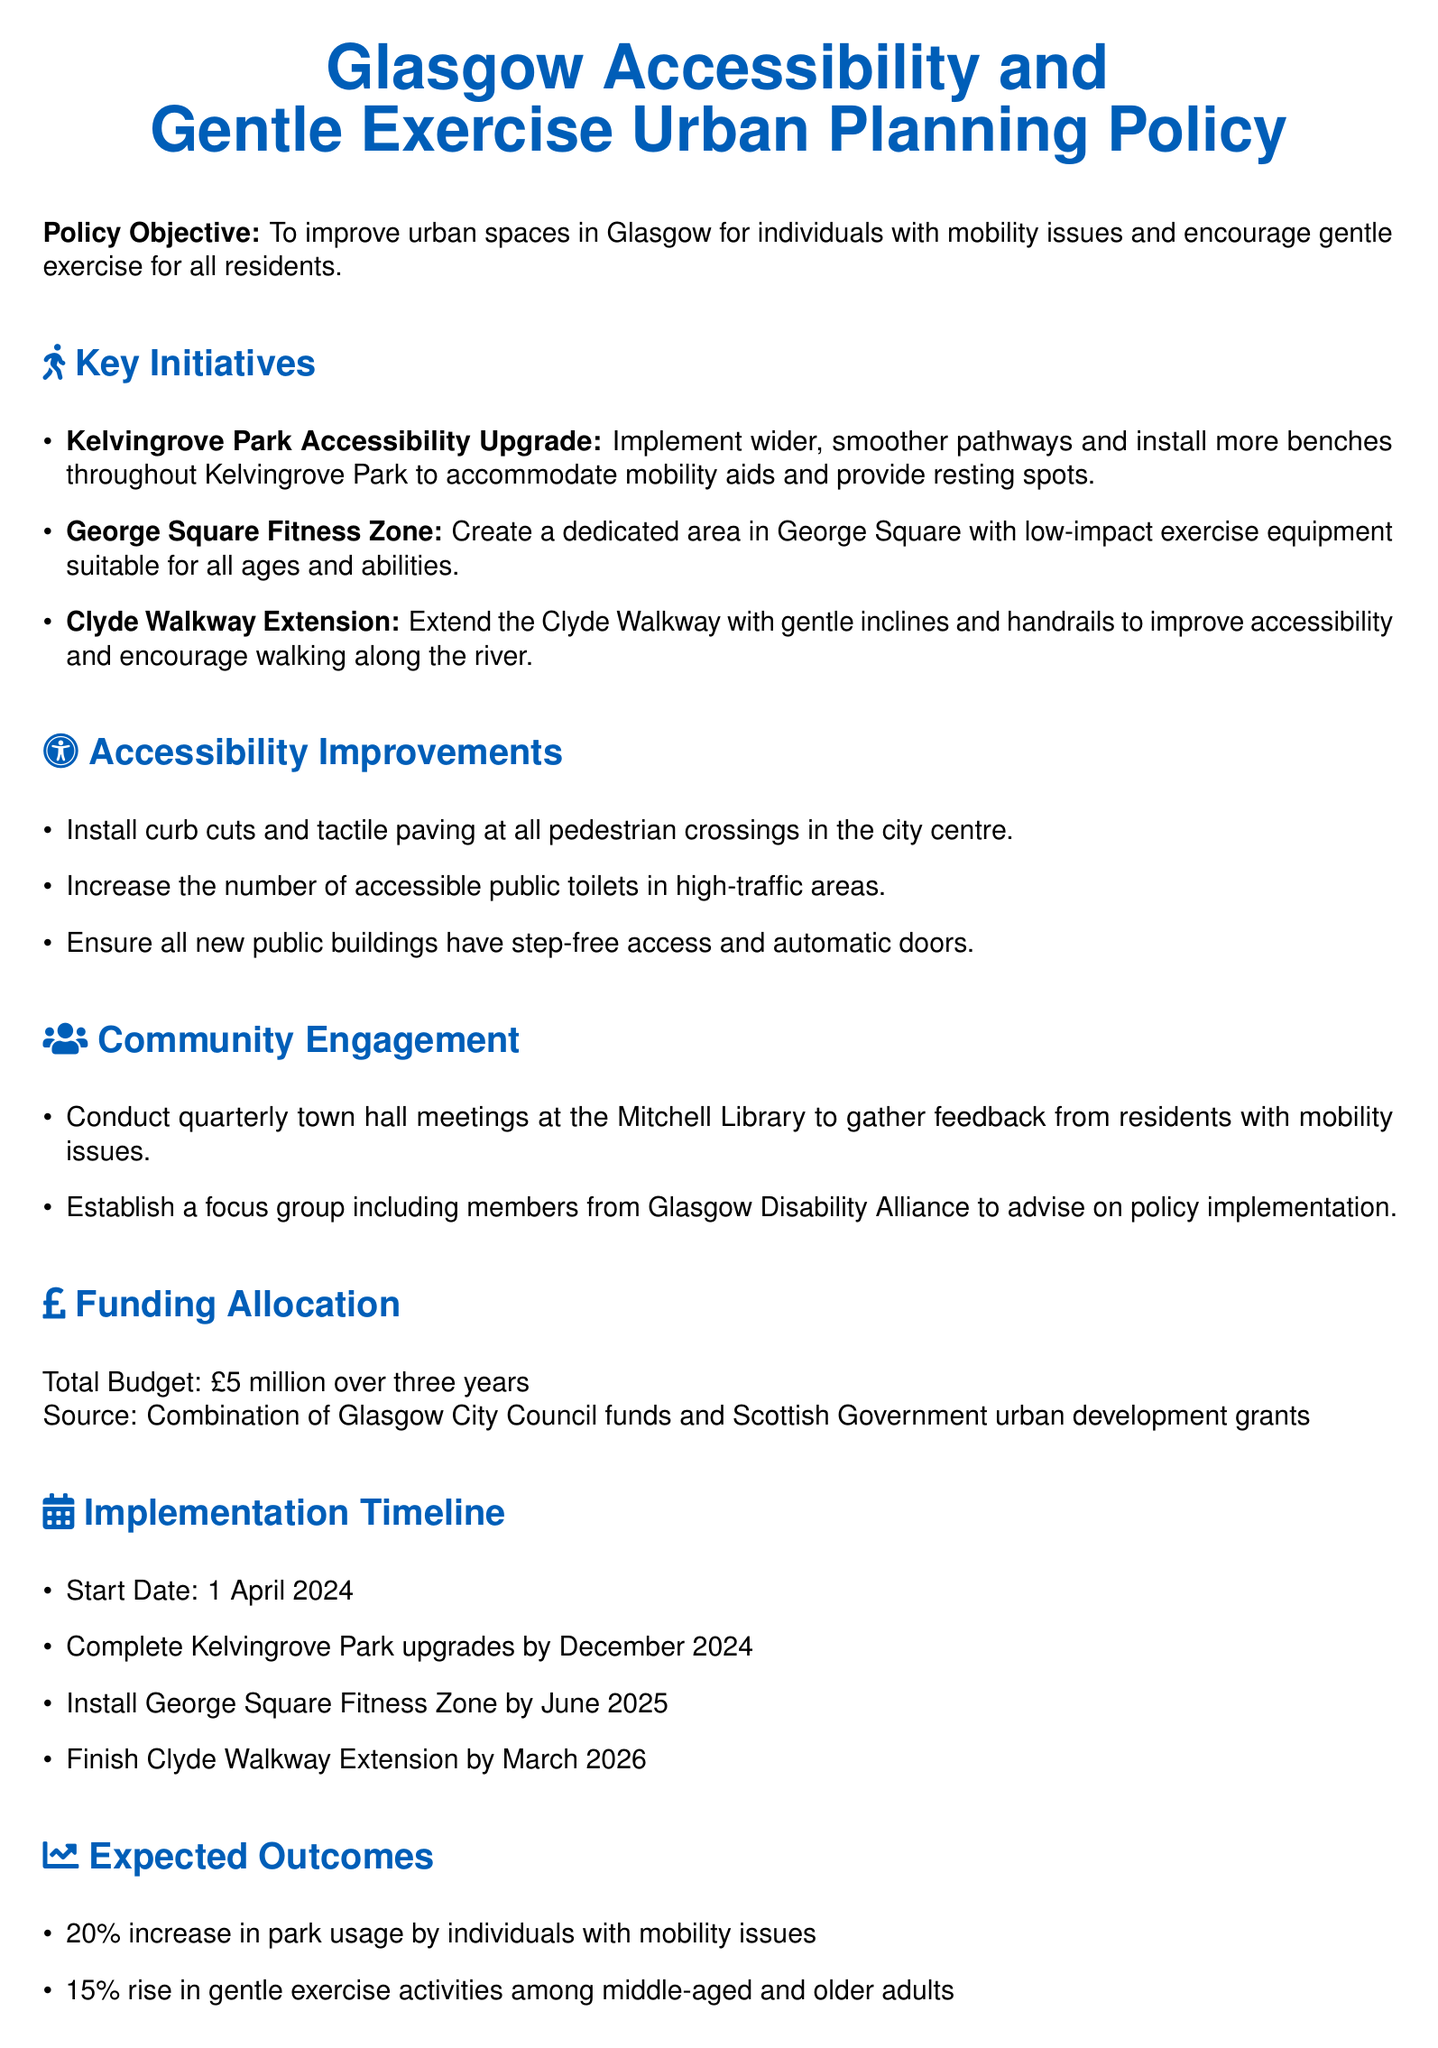What is the policy objective? The policy objective aims to improve urban spaces in Glasgow for individuals with mobility issues and encourage gentle exercise for all residents.
Answer: Improve urban spaces for individuals with mobility issues and encourage gentle exercise What is the budget allocation for the policy? The total budget mentioned in the document is a combination of Glasgow City Council funds and Scottish Government urban development grants totaling £5 million over three years.
Answer: £5 million over three years When is the start date for implementation? The document states that the start date for implementation is 1 April 2024.
Answer: 1 April 2024 How many new accessible public toilets will be introduced? The document mentions increasing the number of accessible public toilets but does not specify the exact number.
Answer: Not specified What improvement is expected in park usage by individuals with mobility issues? Based on the expected outcomes, a 20% increase in park usage by individuals with mobility issues is anticipated.
Answer: 20% What is one initiative proposed for George Square? The document suggests creating a dedicated area in George Square with low-impact exercise equipment suitable for all ages and abilities.
Answer: Create a dedicated area with low-impact exercise equipment Who will be included in the focus group for community engagement? The focus group will include members from Glasgow Disability Alliance to advise on policy implementation.
Answer: Glasgow Disability Alliance What is the completion date for the Kelvingrove Park upgrades? The upgrades for Kelvingrove Park are expected to be completed by December 2024.
Answer: December 2024 